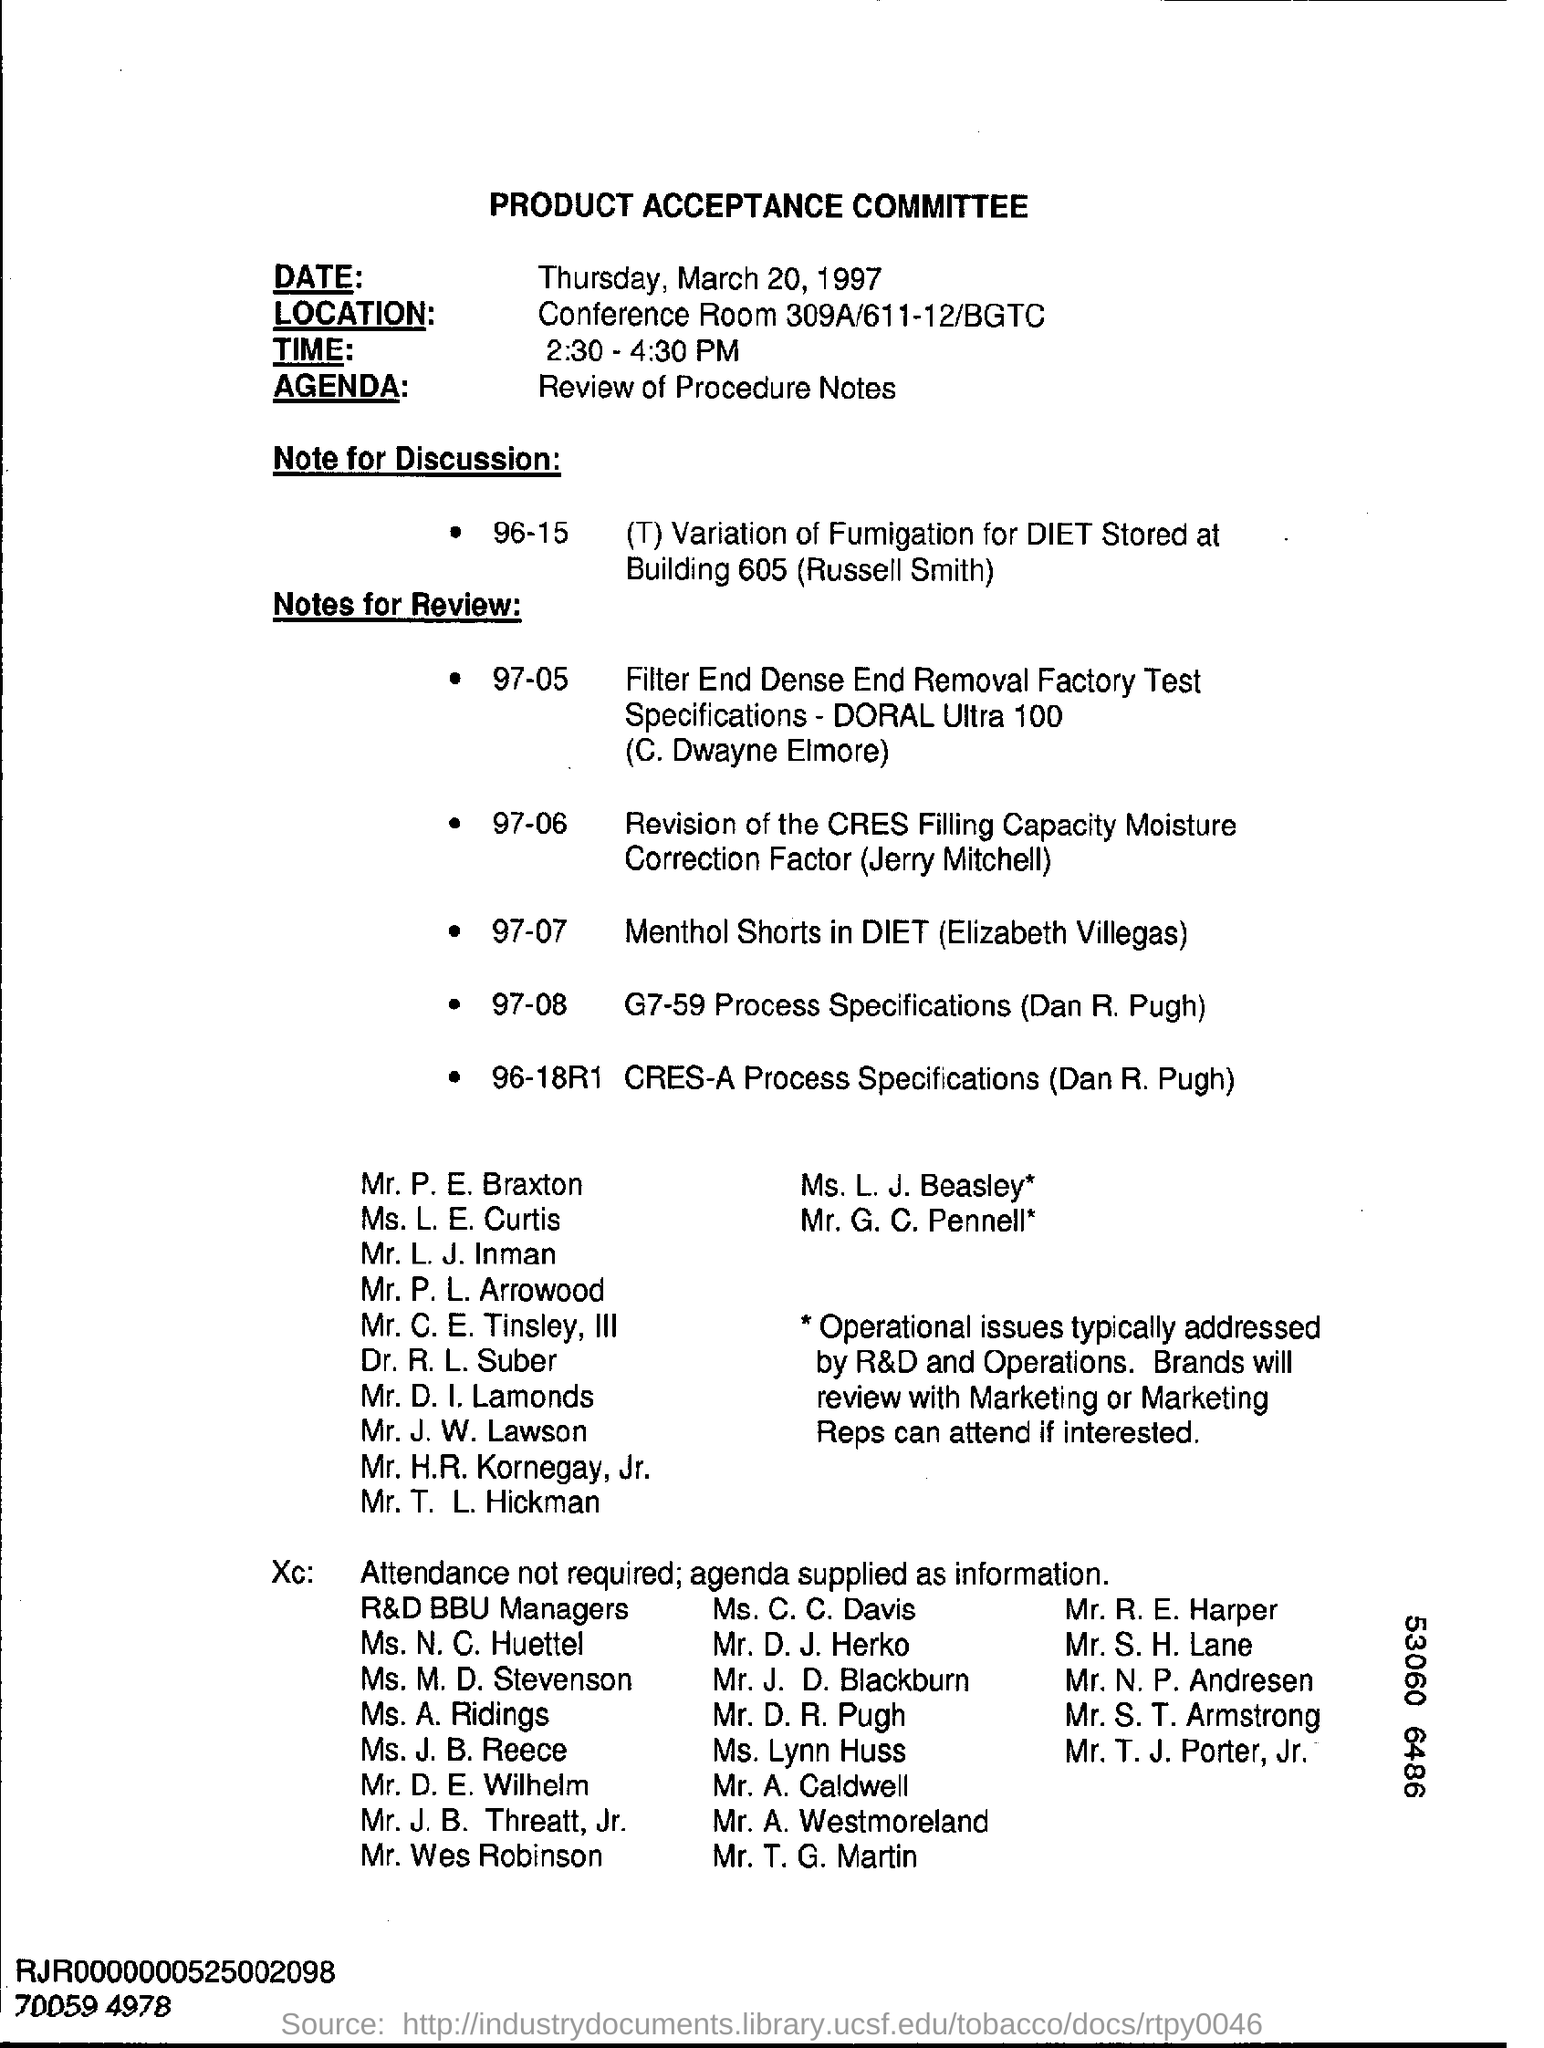What is the main title of this document?
Make the answer very short. PRODUCT ACCEPTANCE COMMITTEE. What is the date mentioned in this document?
Your answer should be very brief. Thursday, March 20, 1997. What is the time mentioned in this document?
Keep it short and to the point. 2:30 - 4:30 PM. What is the location given in the document?
Provide a succinct answer. Conference Room 309A/611-12/BGTC. What is the Agenda as per the document?
Your answer should be compact. Review of Procedure Notes. 